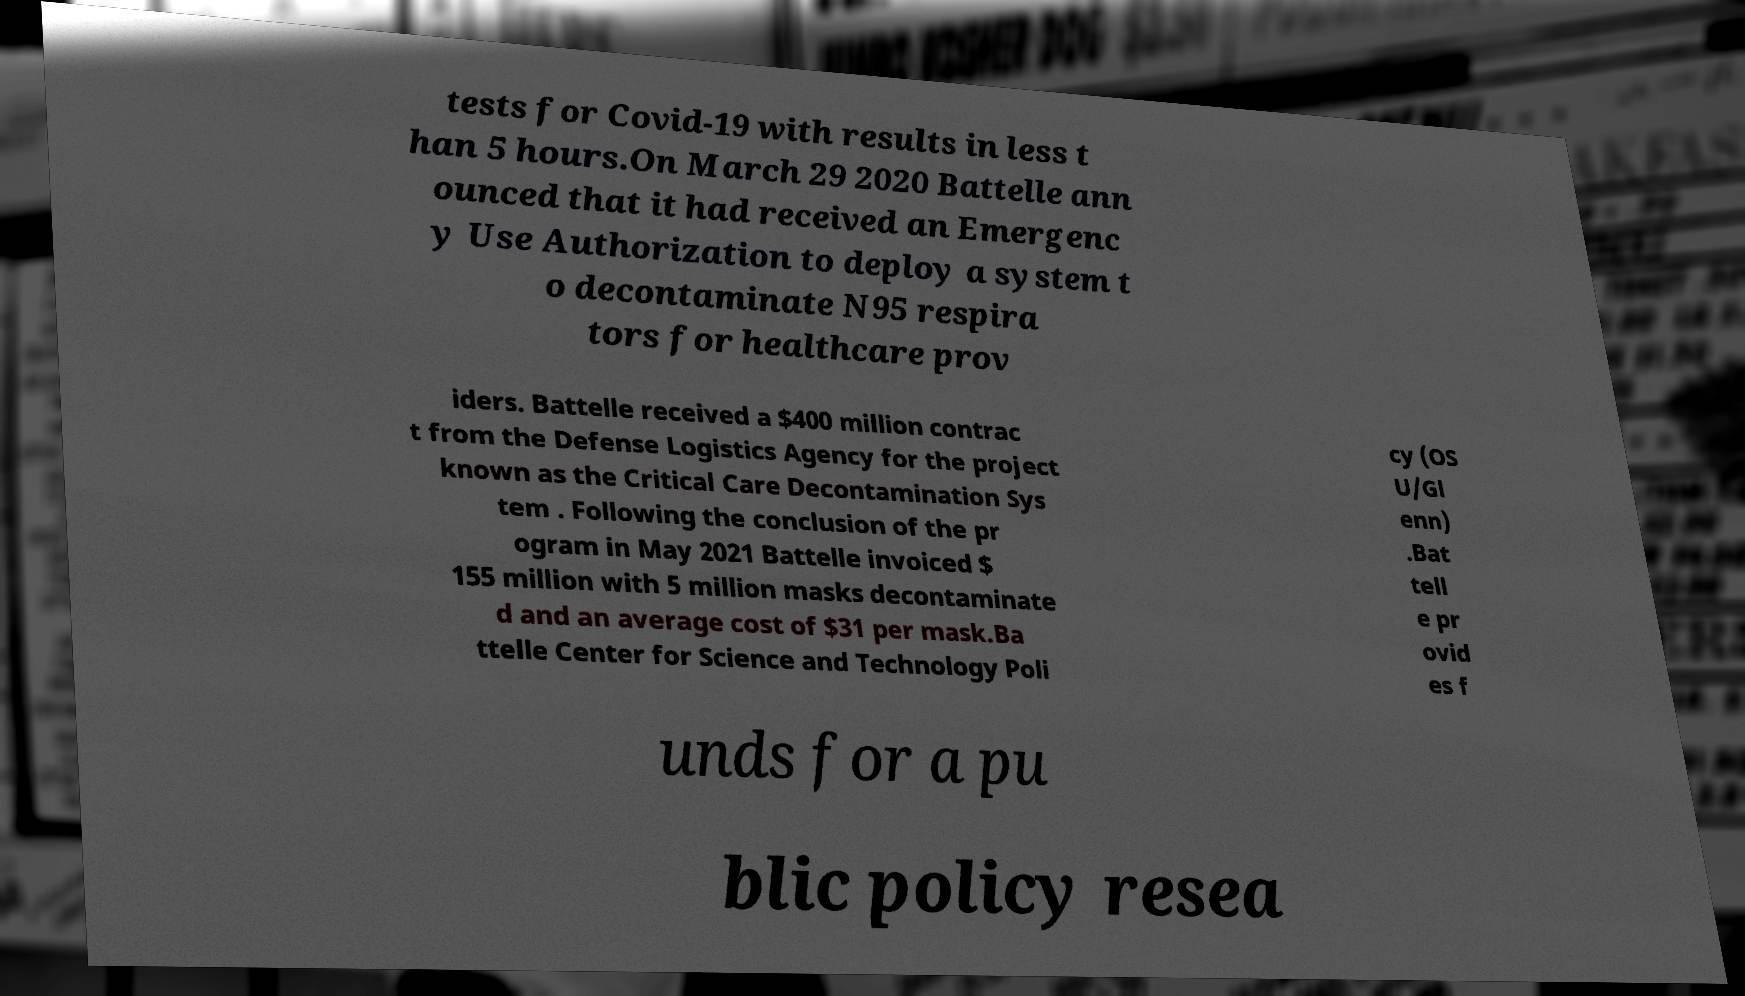Can you read and provide the text displayed in the image?This photo seems to have some interesting text. Can you extract and type it out for me? tests for Covid-19 with results in less t han 5 hours.On March 29 2020 Battelle ann ounced that it had received an Emergenc y Use Authorization to deploy a system t o decontaminate N95 respira tors for healthcare prov iders. Battelle received a $400 million contrac t from the Defense Logistics Agency for the project known as the Critical Care Decontamination Sys tem . Following the conclusion of the pr ogram in May 2021 Battelle invoiced $ 155 million with 5 million masks decontaminate d and an average cost of $31 per mask.Ba ttelle Center for Science and Technology Poli cy (OS U/Gl enn) .Bat tell e pr ovid es f unds for a pu blic policy resea 